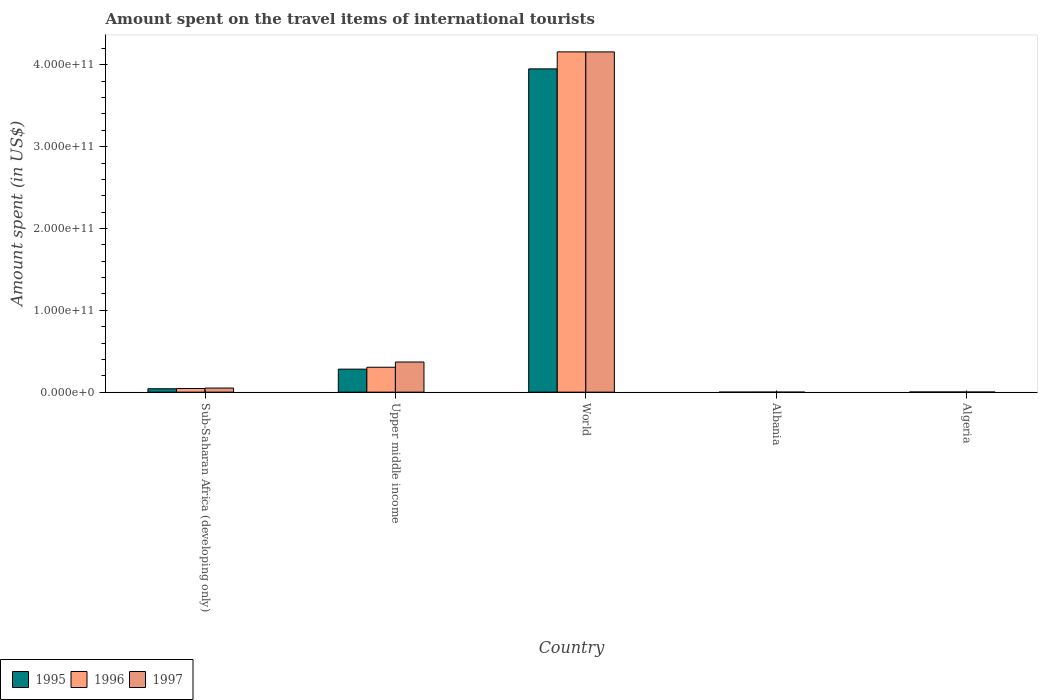How many different coloured bars are there?
Ensure brevity in your answer.  3. How many groups of bars are there?
Your answer should be very brief. 5. Are the number of bars per tick equal to the number of legend labels?
Provide a short and direct response. Yes. How many bars are there on the 2nd tick from the left?
Your response must be concise. 3. What is the label of the 5th group of bars from the left?
Keep it short and to the point. Algeria. What is the amount spent on the travel items of international tourists in 1997 in World?
Offer a terse response. 4.16e+11. Across all countries, what is the maximum amount spent on the travel items of international tourists in 1997?
Make the answer very short. 4.16e+11. Across all countries, what is the minimum amount spent on the travel items of international tourists in 1995?
Your response must be concise. 7.00e+06. In which country was the amount spent on the travel items of international tourists in 1995 maximum?
Provide a short and direct response. World. In which country was the amount spent on the travel items of international tourists in 1996 minimum?
Your response must be concise. Albania. What is the total amount spent on the travel items of international tourists in 1995 in the graph?
Provide a succinct answer. 4.28e+11. What is the difference between the amount spent on the travel items of international tourists in 1997 in Algeria and that in Sub-Saharan Africa (developing only)?
Make the answer very short. -4.86e+09. What is the difference between the amount spent on the travel items of international tourists in 1995 in Algeria and the amount spent on the travel items of international tourists in 1996 in World?
Your answer should be very brief. -4.16e+11. What is the average amount spent on the travel items of international tourists in 1995 per country?
Make the answer very short. 8.55e+1. In how many countries, is the amount spent on the travel items of international tourists in 1996 greater than 300000000000 US$?
Your answer should be compact. 1. What is the ratio of the amount spent on the travel items of international tourists in 1996 in Sub-Saharan Africa (developing only) to that in Upper middle income?
Make the answer very short. 0.15. Is the amount spent on the travel items of international tourists in 1996 in Albania less than that in Algeria?
Your response must be concise. Yes. What is the difference between the highest and the second highest amount spent on the travel items of international tourists in 1996?
Make the answer very short. -4.11e+11. What is the difference between the highest and the lowest amount spent on the travel items of international tourists in 1997?
Your answer should be compact. 4.16e+11. In how many countries, is the amount spent on the travel items of international tourists in 1997 greater than the average amount spent on the travel items of international tourists in 1997 taken over all countries?
Provide a succinct answer. 1. Is the sum of the amount spent on the travel items of international tourists in 1996 in Albania and Sub-Saharan Africa (developing only) greater than the maximum amount spent on the travel items of international tourists in 1995 across all countries?
Your answer should be compact. No. What does the 1st bar from the right in World represents?
Your answer should be very brief. 1997. Is it the case that in every country, the sum of the amount spent on the travel items of international tourists in 1997 and amount spent on the travel items of international tourists in 1996 is greater than the amount spent on the travel items of international tourists in 1995?
Your answer should be compact. Yes. How many bars are there?
Make the answer very short. 15. What is the difference between two consecutive major ticks on the Y-axis?
Offer a very short reply. 1.00e+11. Does the graph contain any zero values?
Make the answer very short. No. How many legend labels are there?
Your answer should be very brief. 3. How are the legend labels stacked?
Give a very brief answer. Horizontal. What is the title of the graph?
Your answer should be very brief. Amount spent on the travel items of international tourists. What is the label or title of the Y-axis?
Provide a succinct answer. Amount spent (in US$). What is the Amount spent (in US$) of 1995 in Sub-Saharan Africa (developing only)?
Provide a short and direct response. 4.14e+09. What is the Amount spent (in US$) in 1996 in Sub-Saharan Africa (developing only)?
Your answer should be compact. 4.44e+09. What is the Amount spent (in US$) in 1997 in Sub-Saharan Africa (developing only)?
Give a very brief answer. 5.01e+09. What is the Amount spent (in US$) in 1995 in Upper middle income?
Your response must be concise. 2.81e+1. What is the Amount spent (in US$) in 1996 in Upper middle income?
Make the answer very short. 3.04e+1. What is the Amount spent (in US$) of 1997 in Upper middle income?
Offer a very short reply. 3.68e+1. What is the Amount spent (in US$) in 1995 in World?
Provide a short and direct response. 3.95e+11. What is the Amount spent (in US$) of 1996 in World?
Offer a very short reply. 4.16e+11. What is the Amount spent (in US$) in 1997 in World?
Give a very brief answer. 4.16e+11. What is the Amount spent (in US$) of 1995 in Albania?
Your response must be concise. 7.00e+06. What is the Amount spent (in US$) of 1995 in Algeria?
Make the answer very short. 1.86e+08. What is the Amount spent (in US$) of 1996 in Algeria?
Keep it short and to the point. 1.88e+08. What is the Amount spent (in US$) of 1997 in Algeria?
Give a very brief answer. 1.44e+08. Across all countries, what is the maximum Amount spent (in US$) in 1995?
Ensure brevity in your answer.  3.95e+11. Across all countries, what is the maximum Amount spent (in US$) of 1996?
Make the answer very short. 4.16e+11. Across all countries, what is the maximum Amount spent (in US$) in 1997?
Your response must be concise. 4.16e+11. Across all countries, what is the minimum Amount spent (in US$) in 1995?
Give a very brief answer. 7.00e+06. Across all countries, what is the minimum Amount spent (in US$) in 1996?
Your answer should be compact. 1.20e+07. What is the total Amount spent (in US$) of 1995 in the graph?
Offer a very short reply. 4.28e+11. What is the total Amount spent (in US$) of 1996 in the graph?
Your response must be concise. 4.51e+11. What is the total Amount spent (in US$) of 1997 in the graph?
Offer a very short reply. 4.58e+11. What is the difference between the Amount spent (in US$) in 1995 in Sub-Saharan Africa (developing only) and that in Upper middle income?
Offer a terse response. -2.40e+1. What is the difference between the Amount spent (in US$) in 1996 in Sub-Saharan Africa (developing only) and that in Upper middle income?
Offer a terse response. -2.60e+1. What is the difference between the Amount spent (in US$) of 1997 in Sub-Saharan Africa (developing only) and that in Upper middle income?
Ensure brevity in your answer.  -3.18e+1. What is the difference between the Amount spent (in US$) of 1995 in Sub-Saharan Africa (developing only) and that in World?
Offer a terse response. -3.91e+11. What is the difference between the Amount spent (in US$) of 1996 in Sub-Saharan Africa (developing only) and that in World?
Give a very brief answer. -4.11e+11. What is the difference between the Amount spent (in US$) in 1997 in Sub-Saharan Africa (developing only) and that in World?
Provide a succinct answer. -4.11e+11. What is the difference between the Amount spent (in US$) of 1995 in Sub-Saharan Africa (developing only) and that in Albania?
Ensure brevity in your answer.  4.13e+09. What is the difference between the Amount spent (in US$) of 1996 in Sub-Saharan Africa (developing only) and that in Albania?
Offer a terse response. 4.43e+09. What is the difference between the Amount spent (in US$) of 1997 in Sub-Saharan Africa (developing only) and that in Albania?
Your response must be concise. 5.00e+09. What is the difference between the Amount spent (in US$) of 1995 in Sub-Saharan Africa (developing only) and that in Algeria?
Give a very brief answer. 3.95e+09. What is the difference between the Amount spent (in US$) in 1996 in Sub-Saharan Africa (developing only) and that in Algeria?
Make the answer very short. 4.25e+09. What is the difference between the Amount spent (in US$) in 1997 in Sub-Saharan Africa (developing only) and that in Algeria?
Make the answer very short. 4.86e+09. What is the difference between the Amount spent (in US$) of 1995 in Upper middle income and that in World?
Provide a succinct answer. -3.67e+11. What is the difference between the Amount spent (in US$) in 1996 in Upper middle income and that in World?
Provide a short and direct response. -3.85e+11. What is the difference between the Amount spent (in US$) in 1997 in Upper middle income and that in World?
Make the answer very short. -3.79e+11. What is the difference between the Amount spent (in US$) of 1995 in Upper middle income and that in Albania?
Give a very brief answer. 2.81e+1. What is the difference between the Amount spent (in US$) of 1996 in Upper middle income and that in Albania?
Give a very brief answer. 3.04e+1. What is the difference between the Amount spent (in US$) in 1997 in Upper middle income and that in Albania?
Ensure brevity in your answer.  3.68e+1. What is the difference between the Amount spent (in US$) of 1995 in Upper middle income and that in Algeria?
Make the answer very short. 2.79e+1. What is the difference between the Amount spent (in US$) of 1996 in Upper middle income and that in Algeria?
Offer a very short reply. 3.03e+1. What is the difference between the Amount spent (in US$) of 1997 in Upper middle income and that in Algeria?
Offer a very short reply. 3.67e+1. What is the difference between the Amount spent (in US$) of 1995 in World and that in Albania?
Your response must be concise. 3.95e+11. What is the difference between the Amount spent (in US$) of 1996 in World and that in Albania?
Your answer should be very brief. 4.16e+11. What is the difference between the Amount spent (in US$) in 1997 in World and that in Albania?
Make the answer very short. 4.16e+11. What is the difference between the Amount spent (in US$) of 1995 in World and that in Algeria?
Offer a terse response. 3.95e+11. What is the difference between the Amount spent (in US$) in 1996 in World and that in Algeria?
Give a very brief answer. 4.16e+11. What is the difference between the Amount spent (in US$) in 1997 in World and that in Algeria?
Your response must be concise. 4.16e+11. What is the difference between the Amount spent (in US$) of 1995 in Albania and that in Algeria?
Make the answer very short. -1.79e+08. What is the difference between the Amount spent (in US$) of 1996 in Albania and that in Algeria?
Keep it short and to the point. -1.76e+08. What is the difference between the Amount spent (in US$) in 1997 in Albania and that in Algeria?
Provide a short and direct response. -1.39e+08. What is the difference between the Amount spent (in US$) of 1995 in Sub-Saharan Africa (developing only) and the Amount spent (in US$) of 1996 in Upper middle income?
Give a very brief answer. -2.63e+1. What is the difference between the Amount spent (in US$) in 1995 in Sub-Saharan Africa (developing only) and the Amount spent (in US$) in 1997 in Upper middle income?
Provide a succinct answer. -3.27e+1. What is the difference between the Amount spent (in US$) of 1996 in Sub-Saharan Africa (developing only) and the Amount spent (in US$) of 1997 in Upper middle income?
Offer a very short reply. -3.24e+1. What is the difference between the Amount spent (in US$) in 1995 in Sub-Saharan Africa (developing only) and the Amount spent (in US$) in 1996 in World?
Give a very brief answer. -4.12e+11. What is the difference between the Amount spent (in US$) in 1995 in Sub-Saharan Africa (developing only) and the Amount spent (in US$) in 1997 in World?
Your response must be concise. -4.12e+11. What is the difference between the Amount spent (in US$) of 1996 in Sub-Saharan Africa (developing only) and the Amount spent (in US$) of 1997 in World?
Your response must be concise. -4.11e+11. What is the difference between the Amount spent (in US$) in 1995 in Sub-Saharan Africa (developing only) and the Amount spent (in US$) in 1996 in Albania?
Offer a terse response. 4.13e+09. What is the difference between the Amount spent (in US$) of 1995 in Sub-Saharan Africa (developing only) and the Amount spent (in US$) of 1997 in Albania?
Make the answer very short. 4.14e+09. What is the difference between the Amount spent (in US$) in 1996 in Sub-Saharan Africa (developing only) and the Amount spent (in US$) in 1997 in Albania?
Your answer should be compact. 4.43e+09. What is the difference between the Amount spent (in US$) in 1995 in Sub-Saharan Africa (developing only) and the Amount spent (in US$) in 1996 in Algeria?
Your answer should be very brief. 3.95e+09. What is the difference between the Amount spent (in US$) in 1995 in Sub-Saharan Africa (developing only) and the Amount spent (in US$) in 1997 in Algeria?
Offer a very short reply. 4.00e+09. What is the difference between the Amount spent (in US$) in 1996 in Sub-Saharan Africa (developing only) and the Amount spent (in US$) in 1997 in Algeria?
Give a very brief answer. 4.30e+09. What is the difference between the Amount spent (in US$) of 1995 in Upper middle income and the Amount spent (in US$) of 1996 in World?
Offer a terse response. -3.88e+11. What is the difference between the Amount spent (in US$) in 1995 in Upper middle income and the Amount spent (in US$) in 1997 in World?
Offer a terse response. -3.88e+11. What is the difference between the Amount spent (in US$) of 1996 in Upper middle income and the Amount spent (in US$) of 1997 in World?
Keep it short and to the point. -3.85e+11. What is the difference between the Amount spent (in US$) of 1995 in Upper middle income and the Amount spent (in US$) of 1996 in Albania?
Provide a succinct answer. 2.81e+1. What is the difference between the Amount spent (in US$) of 1995 in Upper middle income and the Amount spent (in US$) of 1997 in Albania?
Your response must be concise. 2.81e+1. What is the difference between the Amount spent (in US$) of 1996 in Upper middle income and the Amount spent (in US$) of 1997 in Albania?
Make the answer very short. 3.04e+1. What is the difference between the Amount spent (in US$) of 1995 in Upper middle income and the Amount spent (in US$) of 1996 in Algeria?
Your response must be concise. 2.79e+1. What is the difference between the Amount spent (in US$) in 1995 in Upper middle income and the Amount spent (in US$) in 1997 in Algeria?
Provide a short and direct response. 2.80e+1. What is the difference between the Amount spent (in US$) in 1996 in Upper middle income and the Amount spent (in US$) in 1997 in Algeria?
Your answer should be very brief. 3.03e+1. What is the difference between the Amount spent (in US$) in 1995 in World and the Amount spent (in US$) in 1996 in Albania?
Make the answer very short. 3.95e+11. What is the difference between the Amount spent (in US$) in 1995 in World and the Amount spent (in US$) in 1997 in Albania?
Keep it short and to the point. 3.95e+11. What is the difference between the Amount spent (in US$) in 1996 in World and the Amount spent (in US$) in 1997 in Albania?
Offer a terse response. 4.16e+11. What is the difference between the Amount spent (in US$) in 1995 in World and the Amount spent (in US$) in 1996 in Algeria?
Make the answer very short. 3.95e+11. What is the difference between the Amount spent (in US$) of 1995 in World and the Amount spent (in US$) of 1997 in Algeria?
Make the answer very short. 3.95e+11. What is the difference between the Amount spent (in US$) of 1996 in World and the Amount spent (in US$) of 1997 in Algeria?
Your answer should be compact. 4.16e+11. What is the difference between the Amount spent (in US$) in 1995 in Albania and the Amount spent (in US$) in 1996 in Algeria?
Keep it short and to the point. -1.81e+08. What is the difference between the Amount spent (in US$) of 1995 in Albania and the Amount spent (in US$) of 1997 in Algeria?
Your answer should be compact. -1.37e+08. What is the difference between the Amount spent (in US$) of 1996 in Albania and the Amount spent (in US$) of 1997 in Algeria?
Provide a short and direct response. -1.32e+08. What is the average Amount spent (in US$) in 1995 per country?
Your answer should be compact. 8.55e+1. What is the average Amount spent (in US$) in 1996 per country?
Provide a short and direct response. 9.02e+1. What is the average Amount spent (in US$) of 1997 per country?
Provide a short and direct response. 9.16e+1. What is the difference between the Amount spent (in US$) in 1995 and Amount spent (in US$) in 1996 in Sub-Saharan Africa (developing only)?
Give a very brief answer. -3.00e+08. What is the difference between the Amount spent (in US$) of 1995 and Amount spent (in US$) of 1997 in Sub-Saharan Africa (developing only)?
Provide a short and direct response. -8.67e+08. What is the difference between the Amount spent (in US$) of 1996 and Amount spent (in US$) of 1997 in Sub-Saharan Africa (developing only)?
Offer a terse response. -5.67e+08. What is the difference between the Amount spent (in US$) in 1995 and Amount spent (in US$) in 1996 in Upper middle income?
Keep it short and to the point. -2.34e+09. What is the difference between the Amount spent (in US$) of 1995 and Amount spent (in US$) of 1997 in Upper middle income?
Your answer should be very brief. -8.72e+09. What is the difference between the Amount spent (in US$) of 1996 and Amount spent (in US$) of 1997 in Upper middle income?
Your answer should be compact. -6.39e+09. What is the difference between the Amount spent (in US$) of 1995 and Amount spent (in US$) of 1996 in World?
Keep it short and to the point. -2.08e+1. What is the difference between the Amount spent (in US$) in 1995 and Amount spent (in US$) in 1997 in World?
Your response must be concise. -2.08e+1. What is the difference between the Amount spent (in US$) in 1996 and Amount spent (in US$) in 1997 in World?
Your answer should be very brief. 1.91e+07. What is the difference between the Amount spent (in US$) of 1995 and Amount spent (in US$) of 1996 in Albania?
Your answer should be compact. -5.00e+06. What is the difference between the Amount spent (in US$) of 1995 and Amount spent (in US$) of 1997 in Algeria?
Your answer should be very brief. 4.20e+07. What is the difference between the Amount spent (in US$) in 1996 and Amount spent (in US$) in 1997 in Algeria?
Make the answer very short. 4.40e+07. What is the ratio of the Amount spent (in US$) in 1995 in Sub-Saharan Africa (developing only) to that in Upper middle income?
Offer a very short reply. 0.15. What is the ratio of the Amount spent (in US$) of 1996 in Sub-Saharan Africa (developing only) to that in Upper middle income?
Keep it short and to the point. 0.15. What is the ratio of the Amount spent (in US$) in 1997 in Sub-Saharan Africa (developing only) to that in Upper middle income?
Your response must be concise. 0.14. What is the ratio of the Amount spent (in US$) in 1995 in Sub-Saharan Africa (developing only) to that in World?
Your answer should be compact. 0.01. What is the ratio of the Amount spent (in US$) of 1996 in Sub-Saharan Africa (developing only) to that in World?
Your response must be concise. 0.01. What is the ratio of the Amount spent (in US$) of 1997 in Sub-Saharan Africa (developing only) to that in World?
Make the answer very short. 0.01. What is the ratio of the Amount spent (in US$) in 1995 in Sub-Saharan Africa (developing only) to that in Albania?
Your answer should be compact. 591.44. What is the ratio of the Amount spent (in US$) in 1996 in Sub-Saharan Africa (developing only) to that in Albania?
Your answer should be compact. 369.98. What is the ratio of the Amount spent (in US$) in 1997 in Sub-Saharan Africa (developing only) to that in Albania?
Provide a short and direct response. 1001.41. What is the ratio of the Amount spent (in US$) of 1995 in Sub-Saharan Africa (developing only) to that in Algeria?
Your answer should be compact. 22.26. What is the ratio of the Amount spent (in US$) of 1996 in Sub-Saharan Africa (developing only) to that in Algeria?
Your answer should be compact. 23.62. What is the ratio of the Amount spent (in US$) in 1997 in Sub-Saharan Africa (developing only) to that in Algeria?
Keep it short and to the point. 34.77. What is the ratio of the Amount spent (in US$) of 1995 in Upper middle income to that in World?
Your answer should be very brief. 0.07. What is the ratio of the Amount spent (in US$) in 1996 in Upper middle income to that in World?
Offer a very short reply. 0.07. What is the ratio of the Amount spent (in US$) in 1997 in Upper middle income to that in World?
Provide a succinct answer. 0.09. What is the ratio of the Amount spent (in US$) in 1995 in Upper middle income to that in Albania?
Provide a short and direct response. 4015.88. What is the ratio of the Amount spent (in US$) of 1996 in Upper middle income to that in Albania?
Give a very brief answer. 2537.19. What is the ratio of the Amount spent (in US$) of 1997 in Upper middle income to that in Albania?
Provide a succinct answer. 7367.01. What is the ratio of the Amount spent (in US$) in 1995 in Upper middle income to that in Algeria?
Ensure brevity in your answer.  151.14. What is the ratio of the Amount spent (in US$) in 1996 in Upper middle income to that in Algeria?
Provide a short and direct response. 161.95. What is the ratio of the Amount spent (in US$) in 1997 in Upper middle income to that in Algeria?
Provide a short and direct response. 255.8. What is the ratio of the Amount spent (in US$) in 1995 in World to that in Albania?
Give a very brief answer. 5.64e+04. What is the ratio of the Amount spent (in US$) of 1996 in World to that in Albania?
Offer a terse response. 3.47e+04. What is the ratio of the Amount spent (in US$) of 1997 in World to that in Albania?
Offer a terse response. 8.32e+04. What is the ratio of the Amount spent (in US$) in 1995 in World to that in Algeria?
Offer a terse response. 2124.35. What is the ratio of the Amount spent (in US$) of 1996 in World to that in Algeria?
Your answer should be very brief. 2212.28. What is the ratio of the Amount spent (in US$) in 1997 in World to that in Algeria?
Your response must be concise. 2888.12. What is the ratio of the Amount spent (in US$) of 1995 in Albania to that in Algeria?
Ensure brevity in your answer.  0.04. What is the ratio of the Amount spent (in US$) in 1996 in Albania to that in Algeria?
Ensure brevity in your answer.  0.06. What is the ratio of the Amount spent (in US$) of 1997 in Albania to that in Algeria?
Your answer should be compact. 0.03. What is the difference between the highest and the second highest Amount spent (in US$) in 1995?
Keep it short and to the point. 3.67e+11. What is the difference between the highest and the second highest Amount spent (in US$) of 1996?
Offer a very short reply. 3.85e+11. What is the difference between the highest and the second highest Amount spent (in US$) of 1997?
Offer a very short reply. 3.79e+11. What is the difference between the highest and the lowest Amount spent (in US$) of 1995?
Provide a short and direct response. 3.95e+11. What is the difference between the highest and the lowest Amount spent (in US$) in 1996?
Ensure brevity in your answer.  4.16e+11. What is the difference between the highest and the lowest Amount spent (in US$) in 1997?
Your response must be concise. 4.16e+11. 